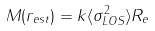<formula> <loc_0><loc_0><loc_500><loc_500>M ( r _ { e s t } ) = k \langle \sigma ^ { 2 } _ { L O S } \rangle R _ { e }</formula> 